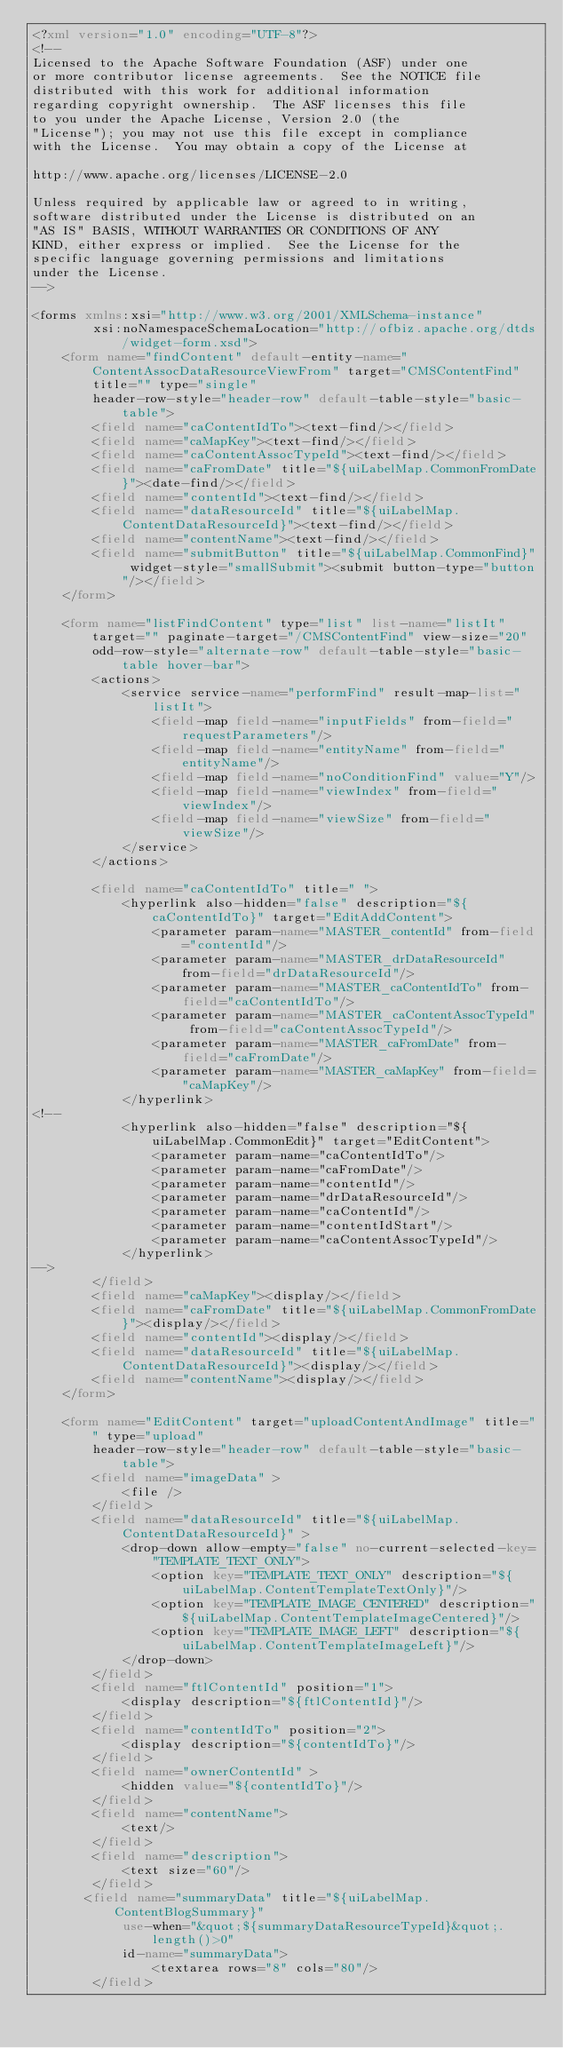Convert code to text. <code><loc_0><loc_0><loc_500><loc_500><_XML_><?xml version="1.0" encoding="UTF-8"?>
<!--
Licensed to the Apache Software Foundation (ASF) under one
or more contributor license agreements.  See the NOTICE file
distributed with this work for additional information
regarding copyright ownership.  The ASF licenses this file
to you under the Apache License, Version 2.0 (the
"License"); you may not use this file except in compliance
with the License.  You may obtain a copy of the License at

http://www.apache.org/licenses/LICENSE-2.0

Unless required by applicable law or agreed to in writing,
software distributed under the License is distributed on an
"AS IS" BASIS, WITHOUT WARRANTIES OR CONDITIONS OF ANY
KIND, either express or implied.  See the License for the
specific language governing permissions and limitations
under the License.
-->

<forms xmlns:xsi="http://www.w3.org/2001/XMLSchema-instance" 
        xsi:noNamespaceSchemaLocation="http://ofbiz.apache.org/dtds/widget-form.xsd">
    <form name="findContent" default-entity-name="ContentAssocDataResourceViewFrom" target="CMSContentFind" title="" type="single"
        header-row-style="header-row" default-table-style="basic-table">
        <field name="caContentIdTo"><text-find/></field>
        <field name="caMapKey"><text-find/></field>
        <field name="caContentAssocTypeId"><text-find/></field>
        <field name="caFromDate" title="${uiLabelMap.CommonFromDate}"><date-find/></field>
        <field name="contentId"><text-find/></field>
        <field name="dataResourceId" title="${uiLabelMap.ContentDataResourceId}"><text-find/></field>
        <field name="contentName"><text-find/></field>
        <field name="submitButton" title="${uiLabelMap.CommonFind}" widget-style="smallSubmit"><submit button-type="button"/></field>
    </form>

    <form name="listFindContent" type="list" list-name="listIt" target="" paginate-target="/CMSContentFind" view-size="20"
        odd-row-style="alternate-row" default-table-style="basic-table hover-bar">
        <actions>
            <service service-name="performFind" result-map-list="listIt">
                <field-map field-name="inputFields" from-field="requestParameters"/>
                <field-map field-name="entityName" from-field="entityName"/>
                <field-map field-name="noConditionFind" value="Y"/>
                <field-map field-name="viewIndex" from-field="viewIndex"/>
                <field-map field-name="viewSize" from-field="viewSize"/>
            </service>
        </actions>

        <field name="caContentIdTo" title=" ">
            <hyperlink also-hidden="false" description="${caContentIdTo}" target="EditAddContent">
                <parameter param-name="MASTER_contentId" from-field="contentId"/>
                <parameter param-name="MASTER_drDataResourceId" from-field="drDataResourceId"/>
                <parameter param-name="MASTER_caContentIdTo" from-field="caContentIdTo"/>
                <parameter param-name="MASTER_caContentAssocTypeId" from-field="caContentAssocTypeId"/>
                <parameter param-name="MASTER_caFromDate" from-field="caFromDate"/>
                <parameter param-name="MASTER_caMapKey" from-field="caMapKey"/>
            </hyperlink>
<!--
            <hyperlink also-hidden="false" description="${uiLabelMap.CommonEdit}" target="EditContent">
                <parameter param-name="caContentIdTo"/>
                <parameter param-name="caFromDate"/>
                <parameter param-name="contentId"/>
                <parameter param-name="drDataResourceId"/>
                <parameter param-name="caContentId"/>
                <parameter param-name="contentIdStart"/>
                <parameter param-name="caContentAssocTypeId"/>
            </hyperlink>
-->
        </field>
        <field name="caMapKey"><display/></field>
        <field name="caFromDate" title="${uiLabelMap.CommonFromDate}"><display/></field>
        <field name="contentId"><display/></field>
        <field name="dataResourceId" title="${uiLabelMap.ContentDataResourceId}"><display/></field>
        <field name="contentName"><display/></field>
    </form>

    <form name="EditContent" target="uploadContentAndImage" title="" type="upload"
        header-row-style="header-row" default-table-style="basic-table">
        <field name="imageData" >
            <file />
        </field>
        <field name="dataResourceId" title="${uiLabelMap.ContentDataResourceId}" >
            <drop-down allow-empty="false" no-current-selected-key="TEMPLATE_TEXT_ONLY">
                <option key="TEMPLATE_TEXT_ONLY" description="${uiLabelMap.ContentTemplateTextOnly}"/>
                <option key="TEMPLATE_IMAGE_CENTERED" description="${uiLabelMap.ContentTemplateImageCentered}"/>
                <option key="TEMPLATE_IMAGE_LEFT" description="${uiLabelMap.ContentTemplateImageLeft}"/>
            </drop-down>
        </field>
        <field name="ftlContentId" position="1">
            <display description="${ftlContentId}"/>
        </field>
        <field name="contentIdTo" position="2">
            <display description="${contentIdTo}"/>
        </field>
        <field name="ownerContentId" >
            <hidden value="${contentIdTo}"/>
        </field>
        <field name="contentName">
            <text/>
        </field>
        <field name="description">
            <text size="60"/>
        </field>
       <field name="summaryData" title="${uiLabelMap.ContentBlogSummary}"
            use-when="&quot;${summaryDataResourceTypeId}&quot;.length()>0"
            id-name="summaryData">
                <textarea rows="8" cols="80"/>
        </field>
</code> 